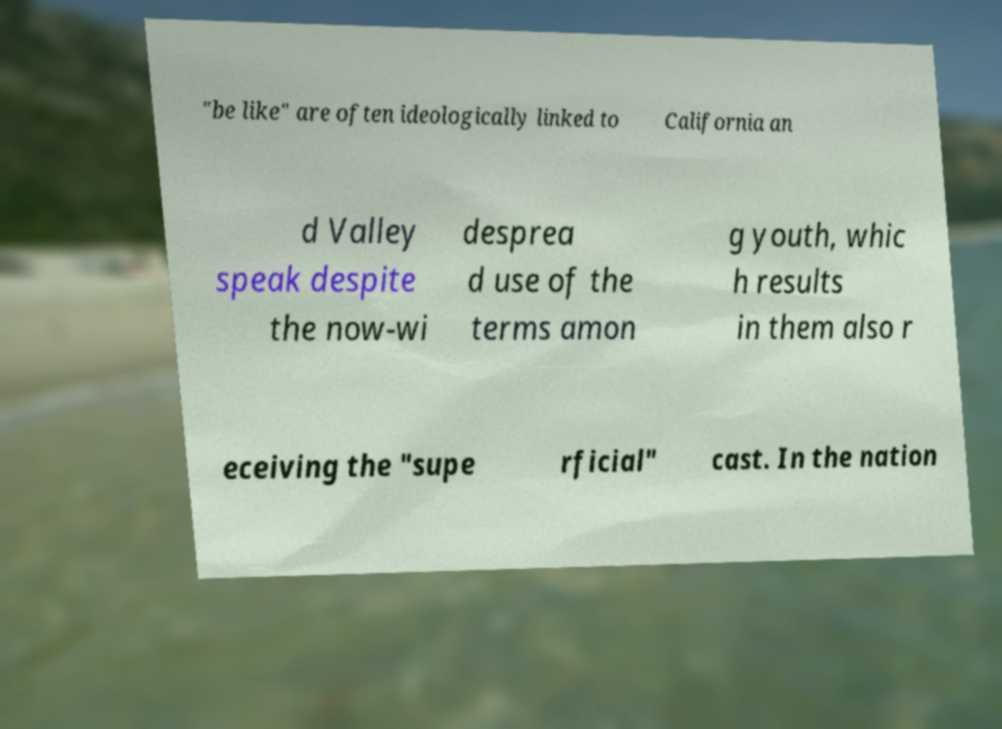Could you assist in decoding the text presented in this image and type it out clearly? "be like" are often ideologically linked to California an d Valley speak despite the now-wi desprea d use of the terms amon g youth, whic h results in them also r eceiving the "supe rficial" cast. In the nation 